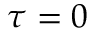<formula> <loc_0><loc_0><loc_500><loc_500>\tau = 0</formula> 